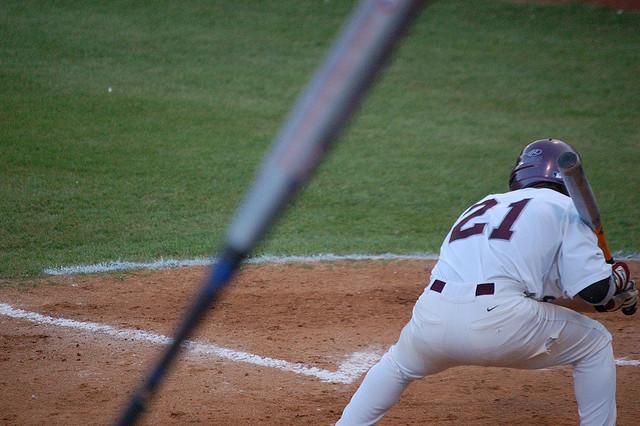What is his jersey number?
Short answer required. 21. Are they playing collegiate baseball?
Be succinct. Yes. What number is on the batter's shirt?
Be succinct. 21. How many bats do you see?
Keep it brief. 2. 